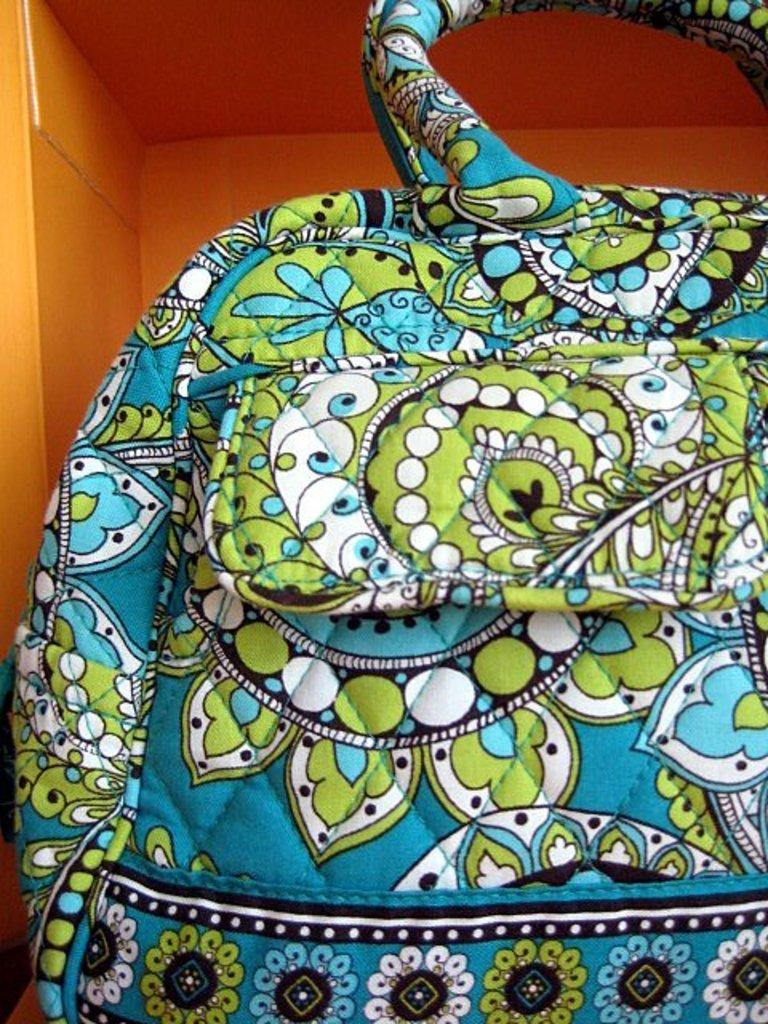What object is visible in the image? There is a bag in the image. What is located behind the bag in the image? There is a cupboard behind the bag in the image. Can you describe the stranger holding a clam in the shade in the image? There is no stranger, clam, or shade present in the image; it only features a bag and a cupboard. 